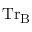Convert formula to latex. <formula><loc_0><loc_0><loc_500><loc_500>T r _ { B }</formula> 